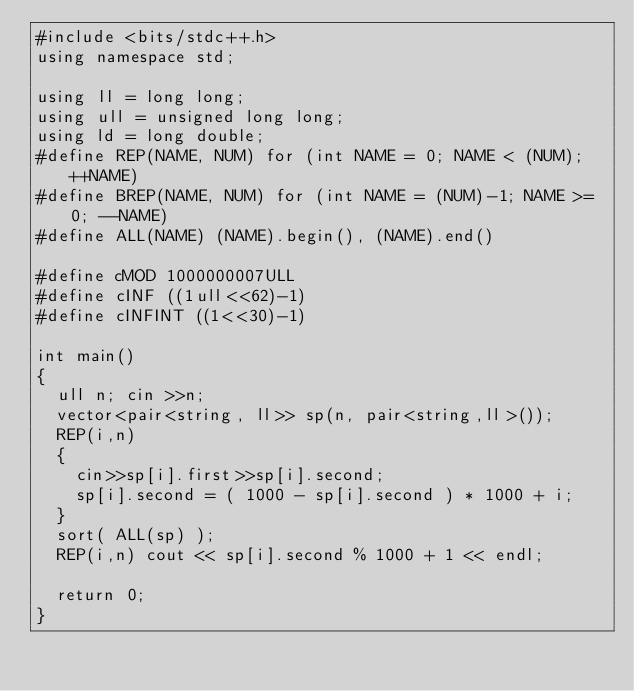<code> <loc_0><loc_0><loc_500><loc_500><_C++_>#include <bits/stdc++.h>
using namespace std;

using ll = long long;
using ull = unsigned long long;
using ld = long double;
#define REP(NAME, NUM) for (int NAME = 0; NAME < (NUM); ++NAME)
#define BREP(NAME, NUM) for (int NAME = (NUM)-1; NAME >= 0; --NAME)
#define ALL(NAME) (NAME).begin(), (NAME).end()

#define cMOD 1000000007ULL
#define cINF ((1ull<<62)-1)
#define cINFINT ((1<<30)-1)

int main()
{
	ull n; cin >>n;
	vector<pair<string, ll>> sp(n, pair<string,ll>());
	REP(i,n)
	{
		cin>>sp[i].first>>sp[i].second;
		sp[i].second = ( 1000 - sp[i].second ) * 1000 + i;
	}
	sort( ALL(sp) );
	REP(i,n) cout << sp[i].second % 1000 + 1 << endl;

	return 0;
}</code> 